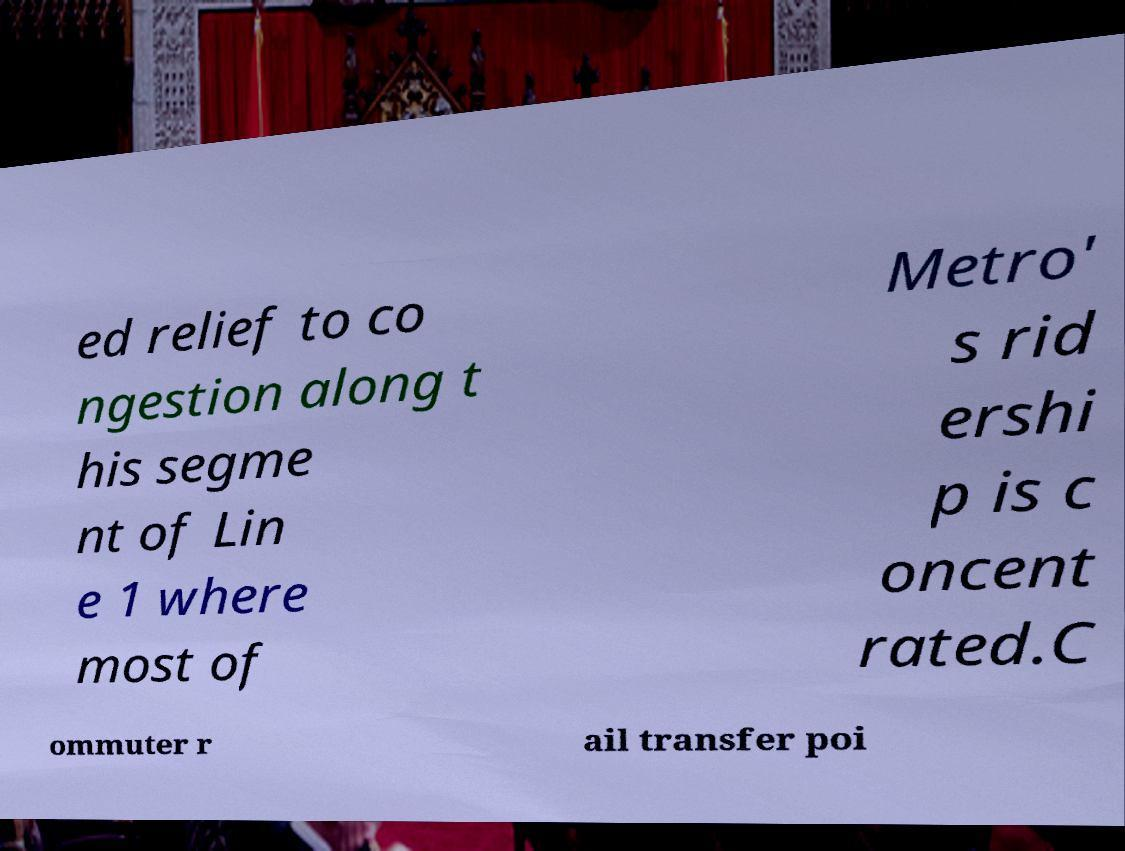Could you extract and type out the text from this image? ed relief to co ngestion along t his segme nt of Lin e 1 where most of Metro' s rid ershi p is c oncent rated.C ommuter r ail transfer poi 